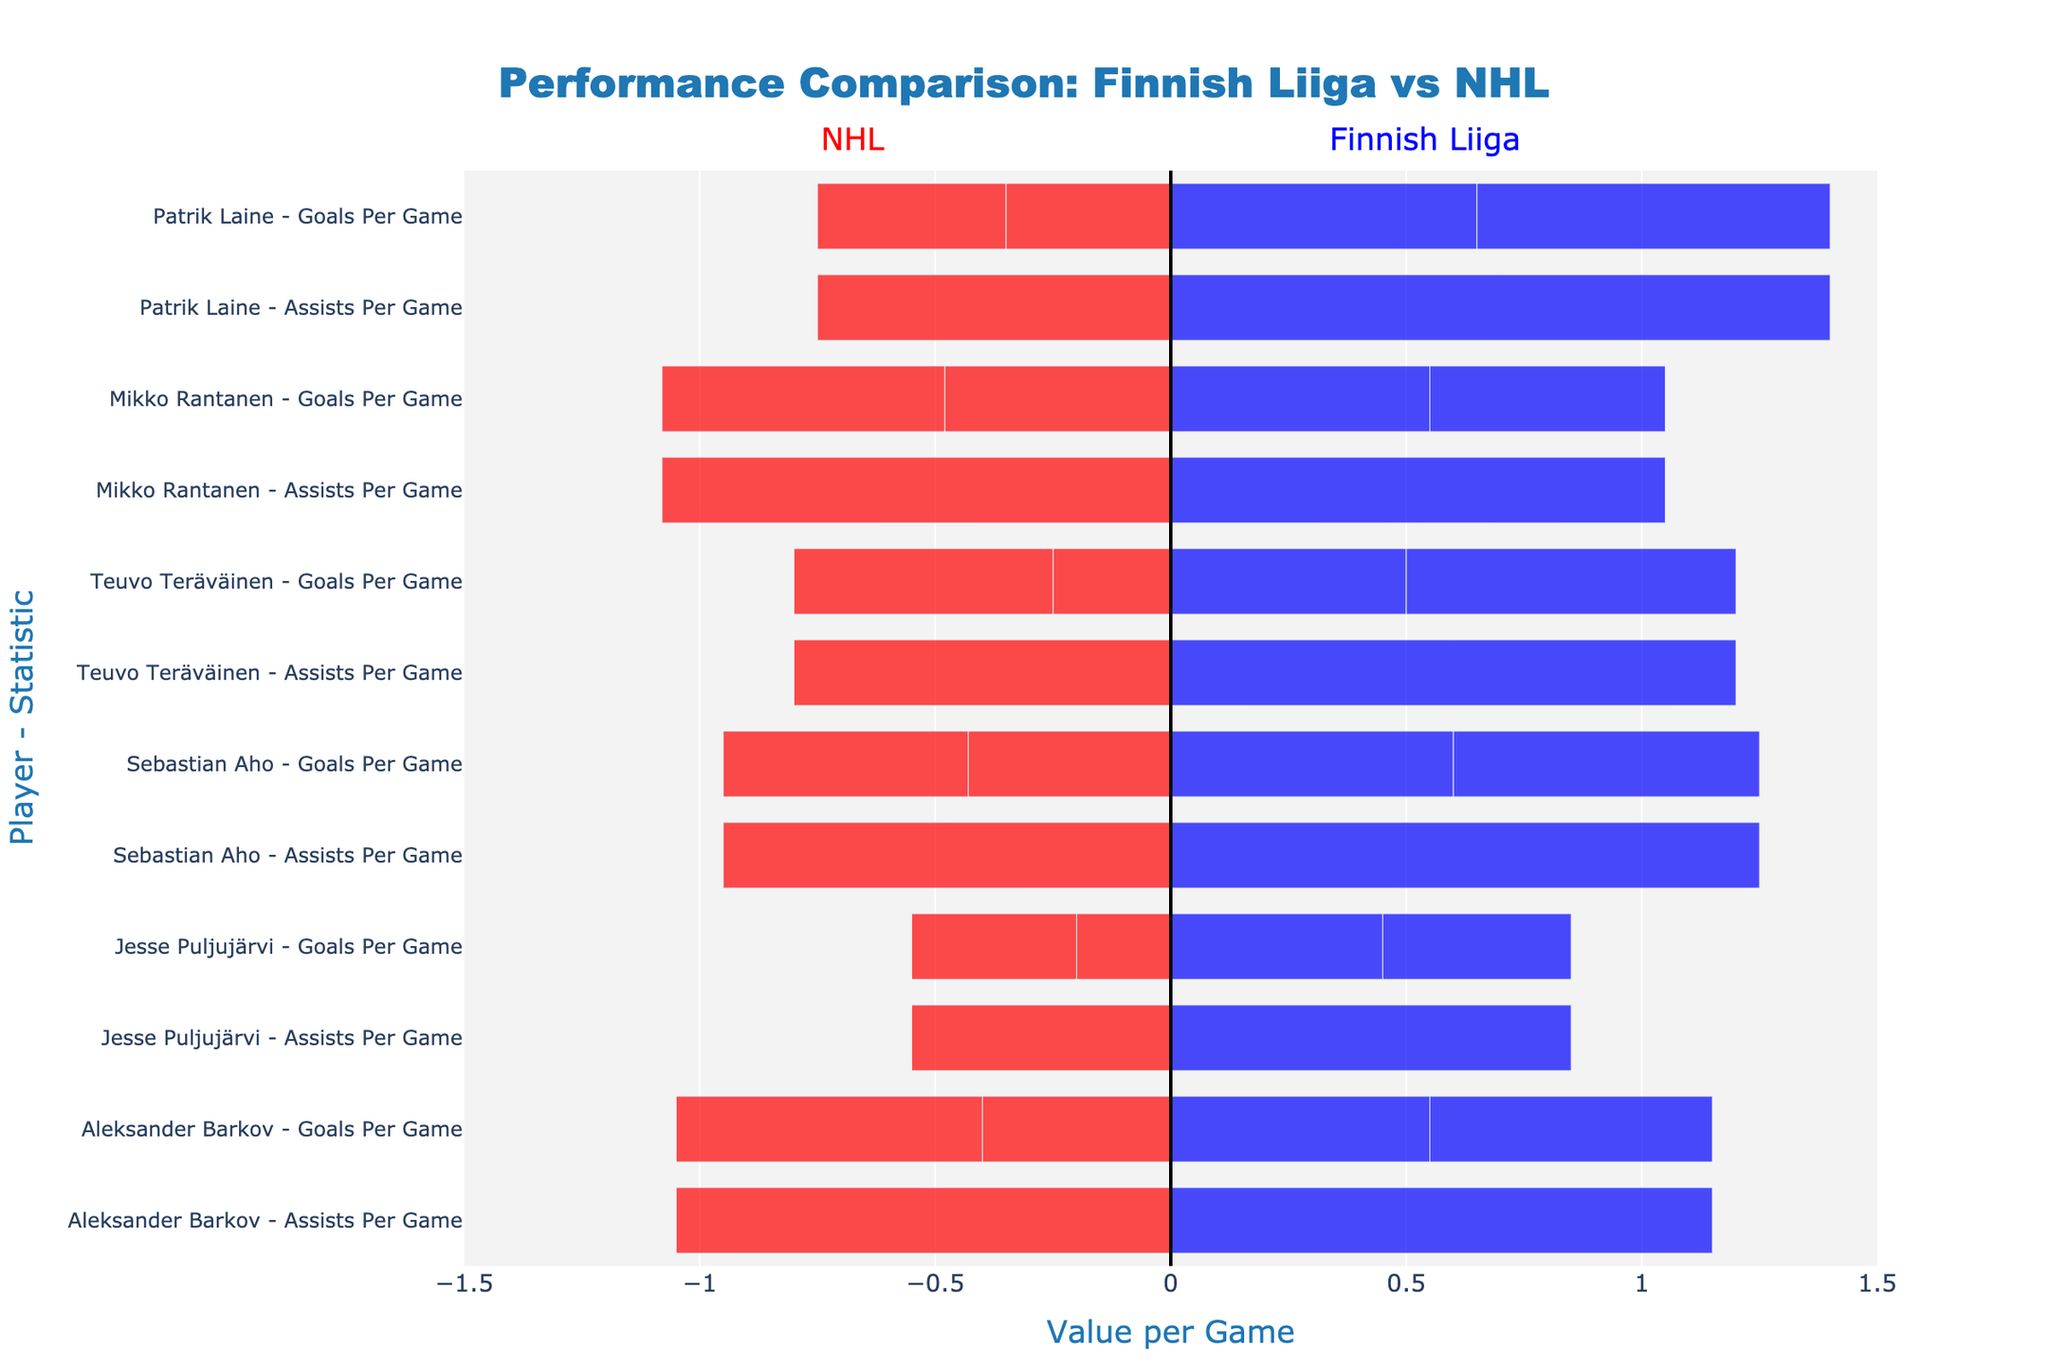Which player has the highest Goals Per Game in the Finnish Liiga? By observing the length of the blue bars for Goals Per Game, we see that Patrik Laine has the longest bar for this statistic in the Finnish Liiga.
Answer: Patrik Laine Which player shows the largest difference in Assists Per Game between Finnish Liiga and NHL? To find this, observe the red and blue bars for Assists Per Game for each player. By comparing the lengths, Teuvo Teräväinen shows the largest difference, with a drop from 0.7 in Finnish Liiga to 0.55 in the NHL.
Answer: Teuvo Teräväinen Who has the least Points Per Game in the NHL? The shortest red bar for Points Per Game needs to be identified. Jesse Puljujärvi has the shortest red bar for this statistic.
Answer: Jesse Puljujärvi How much more Goals Per Game does Sebastian Aho score in Finnish Liiga compared to NHL? Compare the length of the blue bar for Goals Per Game (0.6) with the length of the red bar (0.43). Subtract the values to get the difference: 0.6 - 0.43 = 0.17.
Answer: 0.17 Which player has the most consistent Points Per Game performance between the two leagues? To determine this, look for similar lengths of red and blue bars for Points Per Game for each player. Mikko Rantanen's bars for Points Per Game are very close in length in both leagues (1.05 in Finnish Liiga and 1.08 in NHL).
Answer: Mikko Rantanen Who has the highest Assists Per Game in the NHL? Identify the longest red bar in the Assists Per Game category. Mikko Rantanen has the longest red bar for Assists Per Game in the NHL.
Answer: Mikko Rantanen What is the combined Points Per Game for Aleksander Barkov in both Finnish Liiga and NHL? Add the lengths of the blue and red bars for Points Per Game for Aleksander Barkov: 1.15 (Finnish Liiga) + 1.05 (NHL) = 2.2.
Answer: 2.2 Which player has the smallest difference in Player Performance between the two leagues for Goals Per Game? To answer this, identify the player with the smallest difference between blue and red bar lengths for Goals Per Game. Aleksander Barkov’s difference is smallest with 0.15 (0.55 - 0.4).
Answer: Aleksander Barkov Which player scores more in assists per game in the NHL compared to Finnish Liiga? Check for any red bar in Assists Per Game that is longer than its corresponding blue bar. Only Aleksander Barkov has a longer red bar for Assists Per Game in the NHL (0.65) compared to Finnish Liiga (0.6).
Answer: Aleksander Barkov 